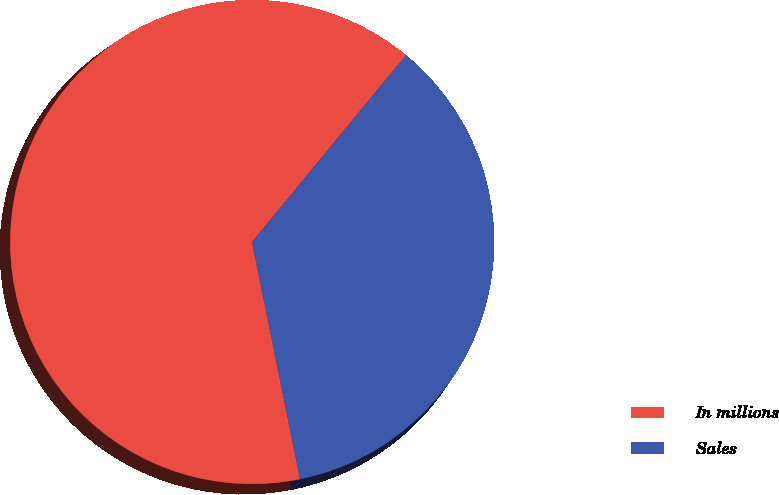<chart> <loc_0><loc_0><loc_500><loc_500><pie_chart><fcel>In millions<fcel>Sales<nl><fcel>64.15%<fcel>35.85%<nl></chart> 